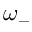Convert formula to latex. <formula><loc_0><loc_0><loc_500><loc_500>\omega _ { - }</formula> 